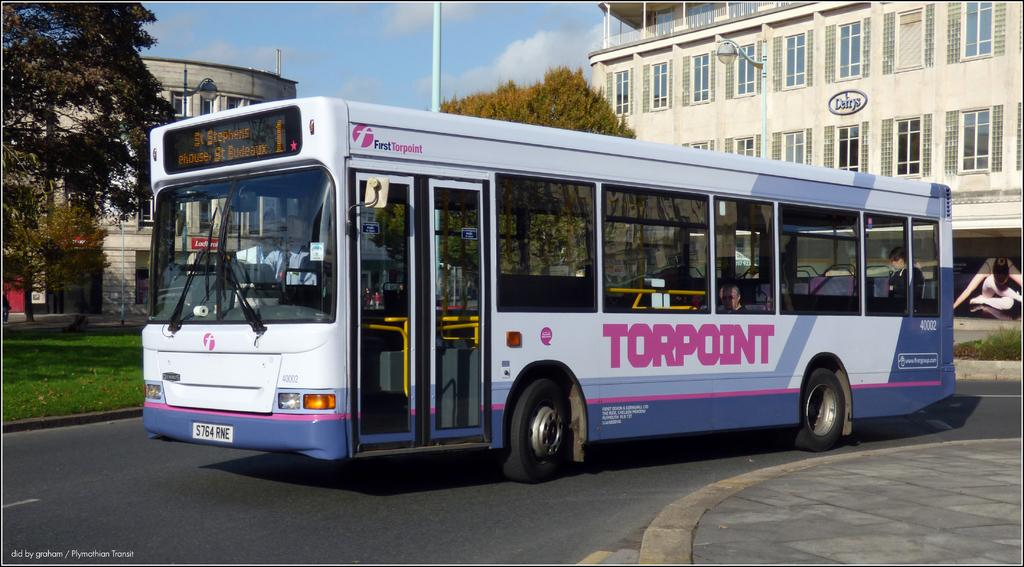What type of vehicle is on the road in the image? There is a bus on the road in the image. What can be seen on the left side of the image? There is grass on the surface at the left side of the image. What is visible in the background of the image? There are trees, buildings, and the sky visible in the background of the image. How many geese are flying over the bus in the image? There are no geese present in the image; it only features a bus on the road, grass on the left side, and trees, buildings, and the sky in the background. 